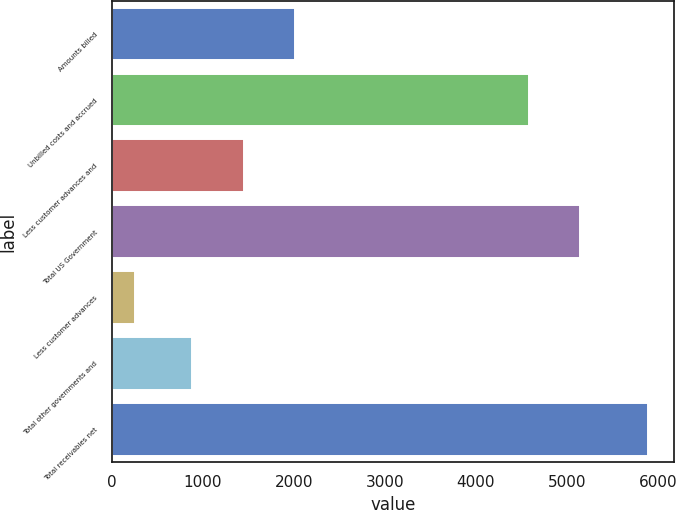Convert chart. <chart><loc_0><loc_0><loc_500><loc_500><bar_chart><fcel>Amounts billed<fcel>Unbilled costs and accrued<fcel>Less customer advances and<fcel>Total US Government<fcel>Less customer advances<fcel>Total other governments and<fcel>Total receivables net<nl><fcel>2011.2<fcel>4577<fcel>1448.1<fcel>5140.1<fcel>253<fcel>885<fcel>5884<nl></chart> 